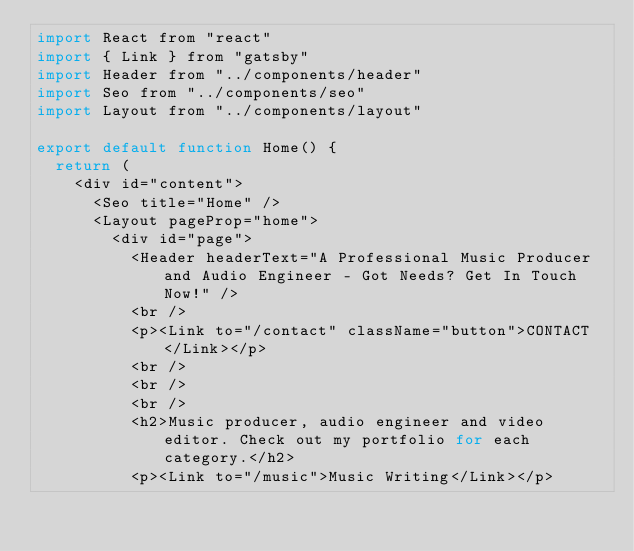Convert code to text. <code><loc_0><loc_0><loc_500><loc_500><_JavaScript_>import React from "react"
import { Link } from "gatsby"
import Header from "../components/header"
import Seo from "../components/seo"
import Layout from "../components/layout"

export default function Home() {
  return (
    <div id="content">
      <Seo title="Home" />
      <Layout pageProp="home">
        <div id="page">       
          <Header headerText="A Professional Music Producer and Audio Engineer - Got Needs? Get In Touch Now!" />
          <br />
          <p><Link to="/contact" className="button">CONTACT</Link></p>
          <br />
          <br />
          <br />
          <h2>Music producer, audio engineer and video editor. Check out my portfolio for each category.</h2>
          <p><Link to="/music">Music Writing</Link></p></code> 